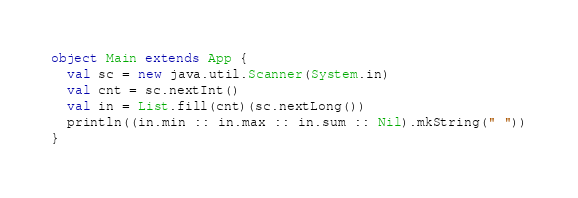<code> <loc_0><loc_0><loc_500><loc_500><_Scala_>object Main extends App {
  val sc = new java.util.Scanner(System.in)
  val cnt = sc.nextInt()
  val in = List.fill(cnt)(sc.nextLong())
  println((in.min :: in.max :: in.sum :: Nil).mkString(" "))
}</code> 